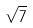Convert formula to latex. <formula><loc_0><loc_0><loc_500><loc_500>\sqrt { 7 }</formula> 